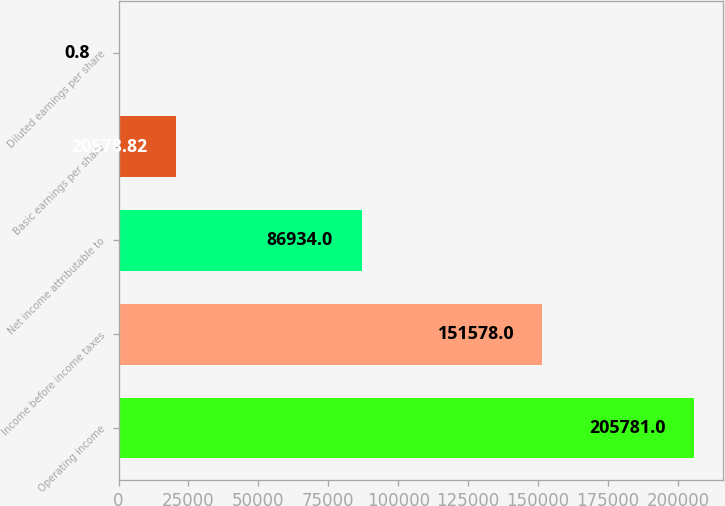Convert chart to OTSL. <chart><loc_0><loc_0><loc_500><loc_500><bar_chart><fcel>Operating income<fcel>Income before income taxes<fcel>Net income attributable to<fcel>Basic earnings per share<fcel>Diluted earnings per share<nl><fcel>205781<fcel>151578<fcel>86934<fcel>20578.8<fcel>0.8<nl></chart> 